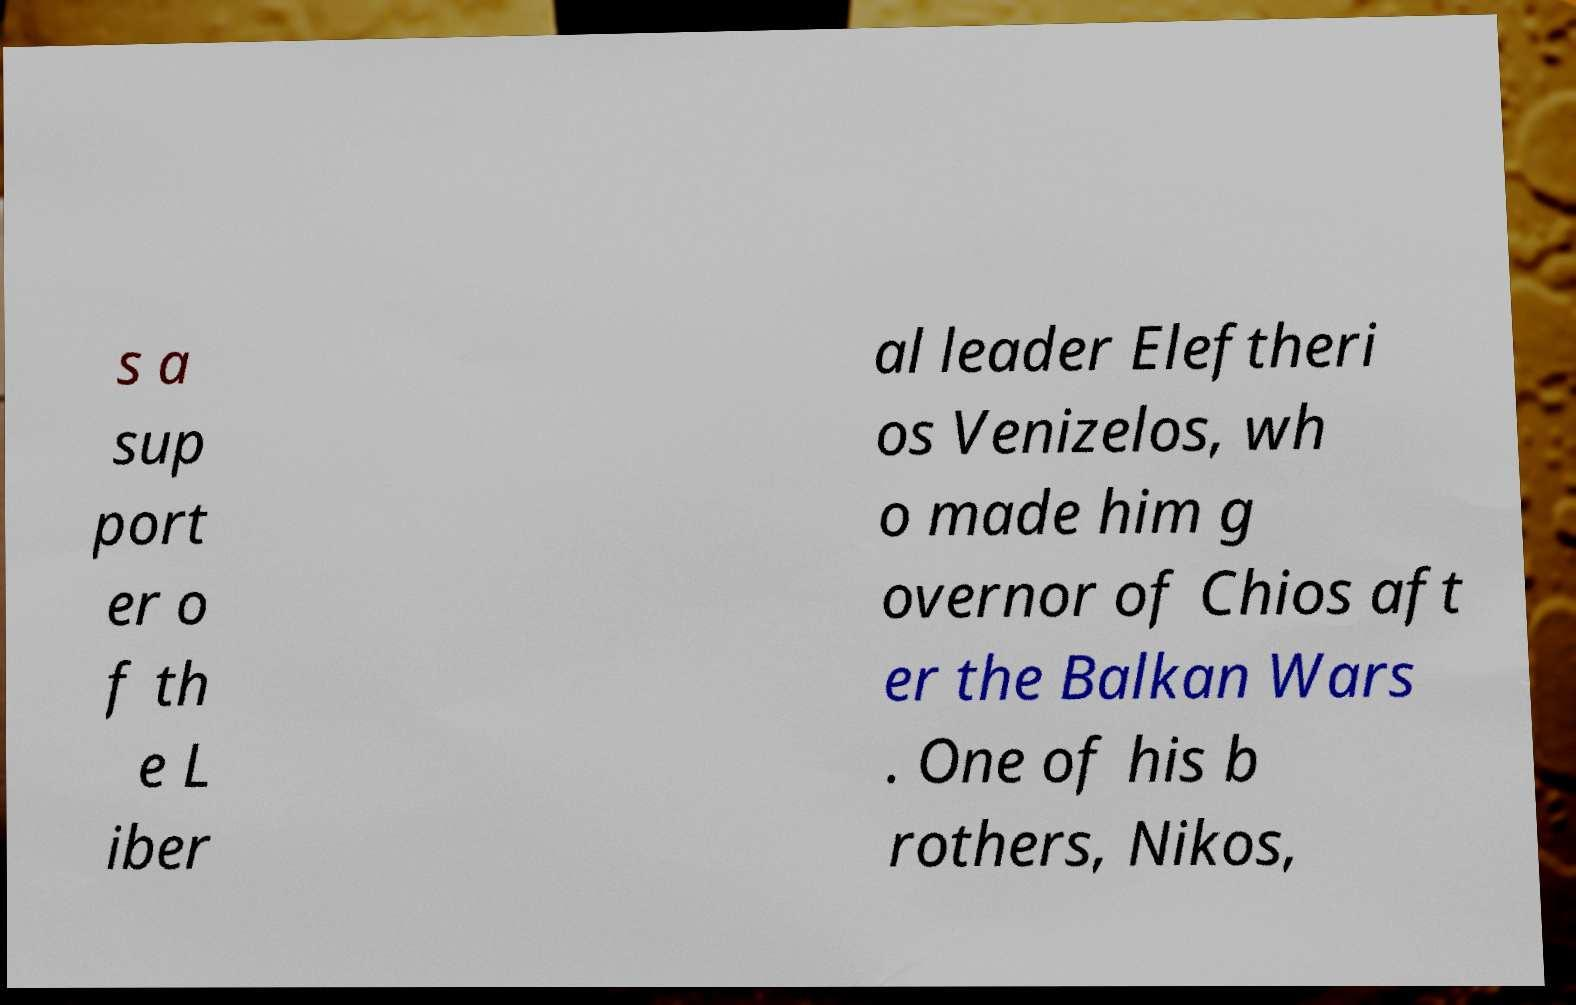There's text embedded in this image that I need extracted. Can you transcribe it verbatim? s a sup port er o f th e L iber al leader Eleftheri os Venizelos, wh o made him g overnor of Chios aft er the Balkan Wars . One of his b rothers, Nikos, 